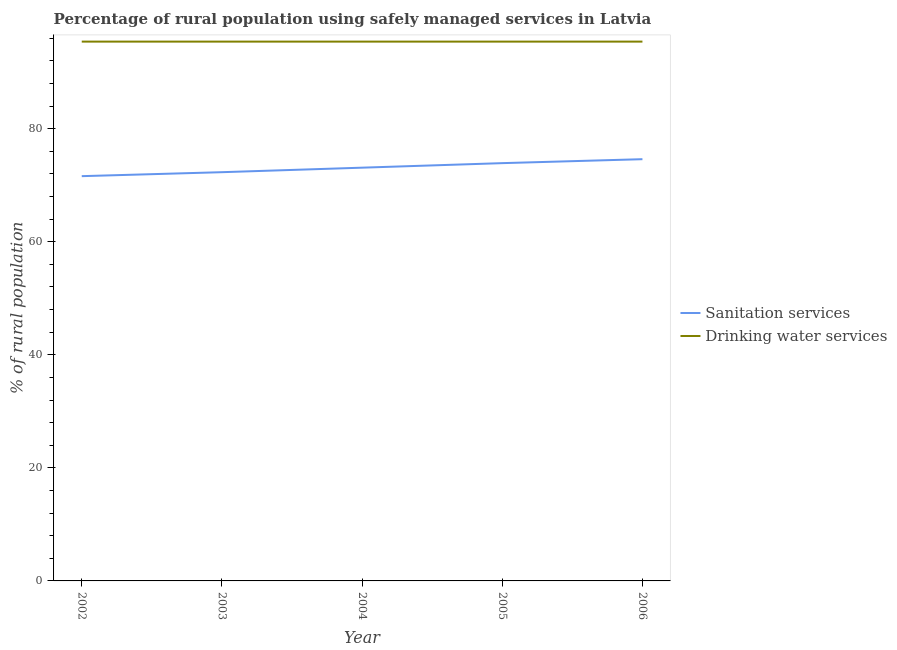Does the line corresponding to percentage of rural population who used sanitation services intersect with the line corresponding to percentage of rural population who used drinking water services?
Provide a succinct answer. No. What is the percentage of rural population who used drinking water services in 2004?
Make the answer very short. 95.4. Across all years, what is the maximum percentage of rural population who used sanitation services?
Offer a terse response. 74.6. Across all years, what is the minimum percentage of rural population who used drinking water services?
Provide a short and direct response. 95.4. In which year was the percentage of rural population who used drinking water services maximum?
Make the answer very short. 2002. What is the total percentage of rural population who used sanitation services in the graph?
Make the answer very short. 365.5. What is the difference between the percentage of rural population who used drinking water services in 2004 and that in 2005?
Keep it short and to the point. 0. What is the difference between the percentage of rural population who used sanitation services in 2004 and the percentage of rural population who used drinking water services in 2005?
Give a very brief answer. -22.3. What is the average percentage of rural population who used sanitation services per year?
Your answer should be compact. 73.1. In the year 2002, what is the difference between the percentage of rural population who used sanitation services and percentage of rural population who used drinking water services?
Make the answer very short. -23.8. What is the ratio of the percentage of rural population who used sanitation services in 2002 to that in 2005?
Give a very brief answer. 0.97. Is the percentage of rural population who used drinking water services in 2002 less than that in 2006?
Provide a succinct answer. No. What is the difference between the highest and the second highest percentage of rural population who used sanitation services?
Provide a short and direct response. 0.7. Is the sum of the percentage of rural population who used sanitation services in 2002 and 2006 greater than the maximum percentage of rural population who used drinking water services across all years?
Provide a succinct answer. Yes. Does the percentage of rural population who used drinking water services monotonically increase over the years?
Keep it short and to the point. No. Is the percentage of rural population who used drinking water services strictly greater than the percentage of rural population who used sanitation services over the years?
Make the answer very short. Yes. Is the percentage of rural population who used sanitation services strictly less than the percentage of rural population who used drinking water services over the years?
Provide a succinct answer. Yes. How many lines are there?
Keep it short and to the point. 2. How many years are there in the graph?
Offer a very short reply. 5. What is the difference between two consecutive major ticks on the Y-axis?
Offer a terse response. 20. How are the legend labels stacked?
Give a very brief answer. Vertical. What is the title of the graph?
Your response must be concise. Percentage of rural population using safely managed services in Latvia. What is the label or title of the Y-axis?
Make the answer very short. % of rural population. What is the % of rural population in Sanitation services in 2002?
Keep it short and to the point. 71.6. What is the % of rural population of Drinking water services in 2002?
Your answer should be very brief. 95.4. What is the % of rural population of Sanitation services in 2003?
Ensure brevity in your answer.  72.3. What is the % of rural population of Drinking water services in 2003?
Offer a terse response. 95.4. What is the % of rural population in Sanitation services in 2004?
Your response must be concise. 73.1. What is the % of rural population of Drinking water services in 2004?
Your answer should be compact. 95.4. What is the % of rural population in Sanitation services in 2005?
Ensure brevity in your answer.  73.9. What is the % of rural population of Drinking water services in 2005?
Offer a terse response. 95.4. What is the % of rural population of Sanitation services in 2006?
Provide a short and direct response. 74.6. What is the % of rural population of Drinking water services in 2006?
Your response must be concise. 95.4. Across all years, what is the maximum % of rural population of Sanitation services?
Make the answer very short. 74.6. Across all years, what is the maximum % of rural population in Drinking water services?
Provide a short and direct response. 95.4. Across all years, what is the minimum % of rural population in Sanitation services?
Give a very brief answer. 71.6. Across all years, what is the minimum % of rural population of Drinking water services?
Provide a short and direct response. 95.4. What is the total % of rural population of Sanitation services in the graph?
Your answer should be very brief. 365.5. What is the total % of rural population in Drinking water services in the graph?
Make the answer very short. 477. What is the difference between the % of rural population of Sanitation services in 2002 and that in 2003?
Offer a terse response. -0.7. What is the difference between the % of rural population of Drinking water services in 2002 and that in 2003?
Offer a very short reply. 0. What is the difference between the % of rural population in Sanitation services in 2002 and that in 2004?
Your answer should be compact. -1.5. What is the difference between the % of rural population in Drinking water services in 2002 and that in 2004?
Provide a short and direct response. 0. What is the difference between the % of rural population in Drinking water services in 2002 and that in 2005?
Provide a succinct answer. 0. What is the difference between the % of rural population of Sanitation services in 2002 and that in 2006?
Provide a succinct answer. -3. What is the difference between the % of rural population of Sanitation services in 2003 and that in 2005?
Your answer should be very brief. -1.6. What is the difference between the % of rural population of Drinking water services in 2003 and that in 2005?
Your answer should be compact. 0. What is the difference between the % of rural population of Sanitation services in 2003 and that in 2006?
Make the answer very short. -2.3. What is the difference between the % of rural population in Sanitation services in 2004 and that in 2005?
Your response must be concise. -0.8. What is the difference between the % of rural population in Drinking water services in 2004 and that in 2005?
Your answer should be very brief. 0. What is the difference between the % of rural population in Sanitation services in 2004 and that in 2006?
Offer a very short reply. -1.5. What is the difference between the % of rural population of Drinking water services in 2005 and that in 2006?
Provide a short and direct response. 0. What is the difference between the % of rural population in Sanitation services in 2002 and the % of rural population in Drinking water services in 2003?
Make the answer very short. -23.8. What is the difference between the % of rural population of Sanitation services in 2002 and the % of rural population of Drinking water services in 2004?
Your answer should be compact. -23.8. What is the difference between the % of rural population in Sanitation services in 2002 and the % of rural population in Drinking water services in 2005?
Make the answer very short. -23.8. What is the difference between the % of rural population in Sanitation services in 2002 and the % of rural population in Drinking water services in 2006?
Your answer should be very brief. -23.8. What is the difference between the % of rural population in Sanitation services in 2003 and the % of rural population in Drinking water services in 2004?
Make the answer very short. -23.1. What is the difference between the % of rural population of Sanitation services in 2003 and the % of rural population of Drinking water services in 2005?
Give a very brief answer. -23.1. What is the difference between the % of rural population of Sanitation services in 2003 and the % of rural population of Drinking water services in 2006?
Provide a short and direct response. -23.1. What is the difference between the % of rural population of Sanitation services in 2004 and the % of rural population of Drinking water services in 2005?
Keep it short and to the point. -22.3. What is the difference between the % of rural population in Sanitation services in 2004 and the % of rural population in Drinking water services in 2006?
Provide a succinct answer. -22.3. What is the difference between the % of rural population of Sanitation services in 2005 and the % of rural population of Drinking water services in 2006?
Your answer should be very brief. -21.5. What is the average % of rural population in Sanitation services per year?
Provide a short and direct response. 73.1. What is the average % of rural population in Drinking water services per year?
Your answer should be very brief. 95.4. In the year 2002, what is the difference between the % of rural population in Sanitation services and % of rural population in Drinking water services?
Your answer should be compact. -23.8. In the year 2003, what is the difference between the % of rural population of Sanitation services and % of rural population of Drinking water services?
Offer a very short reply. -23.1. In the year 2004, what is the difference between the % of rural population in Sanitation services and % of rural population in Drinking water services?
Your answer should be very brief. -22.3. In the year 2005, what is the difference between the % of rural population in Sanitation services and % of rural population in Drinking water services?
Provide a succinct answer. -21.5. In the year 2006, what is the difference between the % of rural population in Sanitation services and % of rural population in Drinking water services?
Your answer should be very brief. -20.8. What is the ratio of the % of rural population in Sanitation services in 2002 to that in 2003?
Offer a very short reply. 0.99. What is the ratio of the % of rural population of Sanitation services in 2002 to that in 2004?
Provide a succinct answer. 0.98. What is the ratio of the % of rural population in Sanitation services in 2002 to that in 2005?
Make the answer very short. 0.97. What is the ratio of the % of rural population in Sanitation services in 2002 to that in 2006?
Offer a very short reply. 0.96. What is the ratio of the % of rural population of Drinking water services in 2002 to that in 2006?
Ensure brevity in your answer.  1. What is the ratio of the % of rural population of Sanitation services in 2003 to that in 2004?
Your response must be concise. 0.99. What is the ratio of the % of rural population in Sanitation services in 2003 to that in 2005?
Give a very brief answer. 0.98. What is the ratio of the % of rural population of Sanitation services in 2003 to that in 2006?
Give a very brief answer. 0.97. What is the ratio of the % of rural population in Drinking water services in 2003 to that in 2006?
Provide a succinct answer. 1. What is the ratio of the % of rural population in Sanitation services in 2004 to that in 2005?
Your answer should be very brief. 0.99. What is the ratio of the % of rural population of Drinking water services in 2004 to that in 2005?
Keep it short and to the point. 1. What is the ratio of the % of rural population of Sanitation services in 2004 to that in 2006?
Give a very brief answer. 0.98. What is the ratio of the % of rural population of Drinking water services in 2004 to that in 2006?
Your answer should be very brief. 1. What is the ratio of the % of rural population in Sanitation services in 2005 to that in 2006?
Your answer should be very brief. 0.99. What is the ratio of the % of rural population of Drinking water services in 2005 to that in 2006?
Ensure brevity in your answer.  1. What is the difference between the highest and the lowest % of rural population in Sanitation services?
Give a very brief answer. 3. 